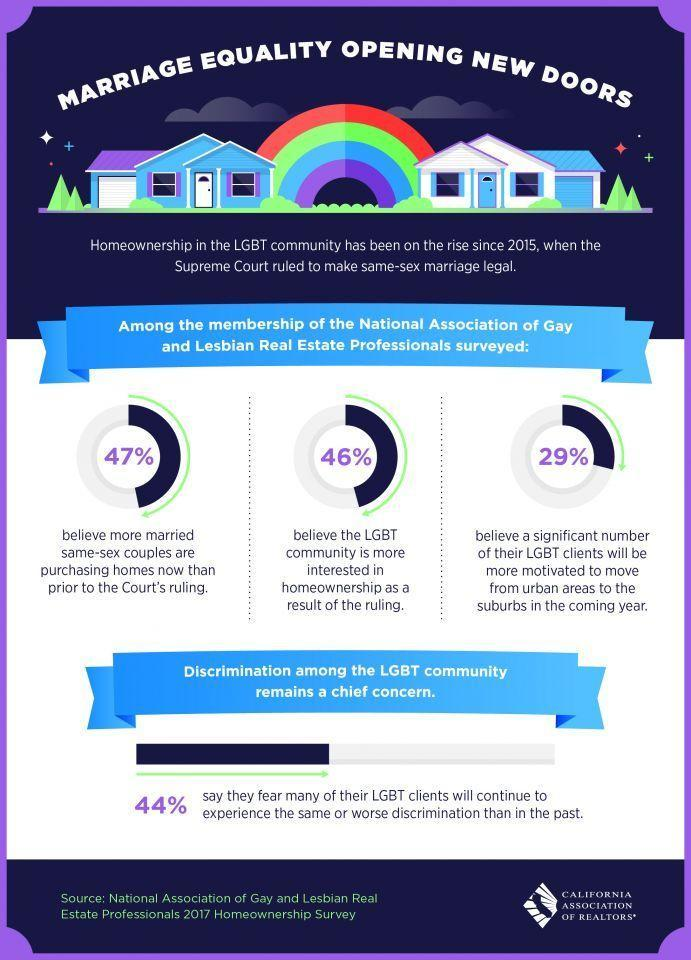What percentage sees a likelihood of LGBTs moving to suburbs from urban areas?
Answer the question with a short phrase. 29% What percentage see an increased interest by LGBT in homeownership? 46% 